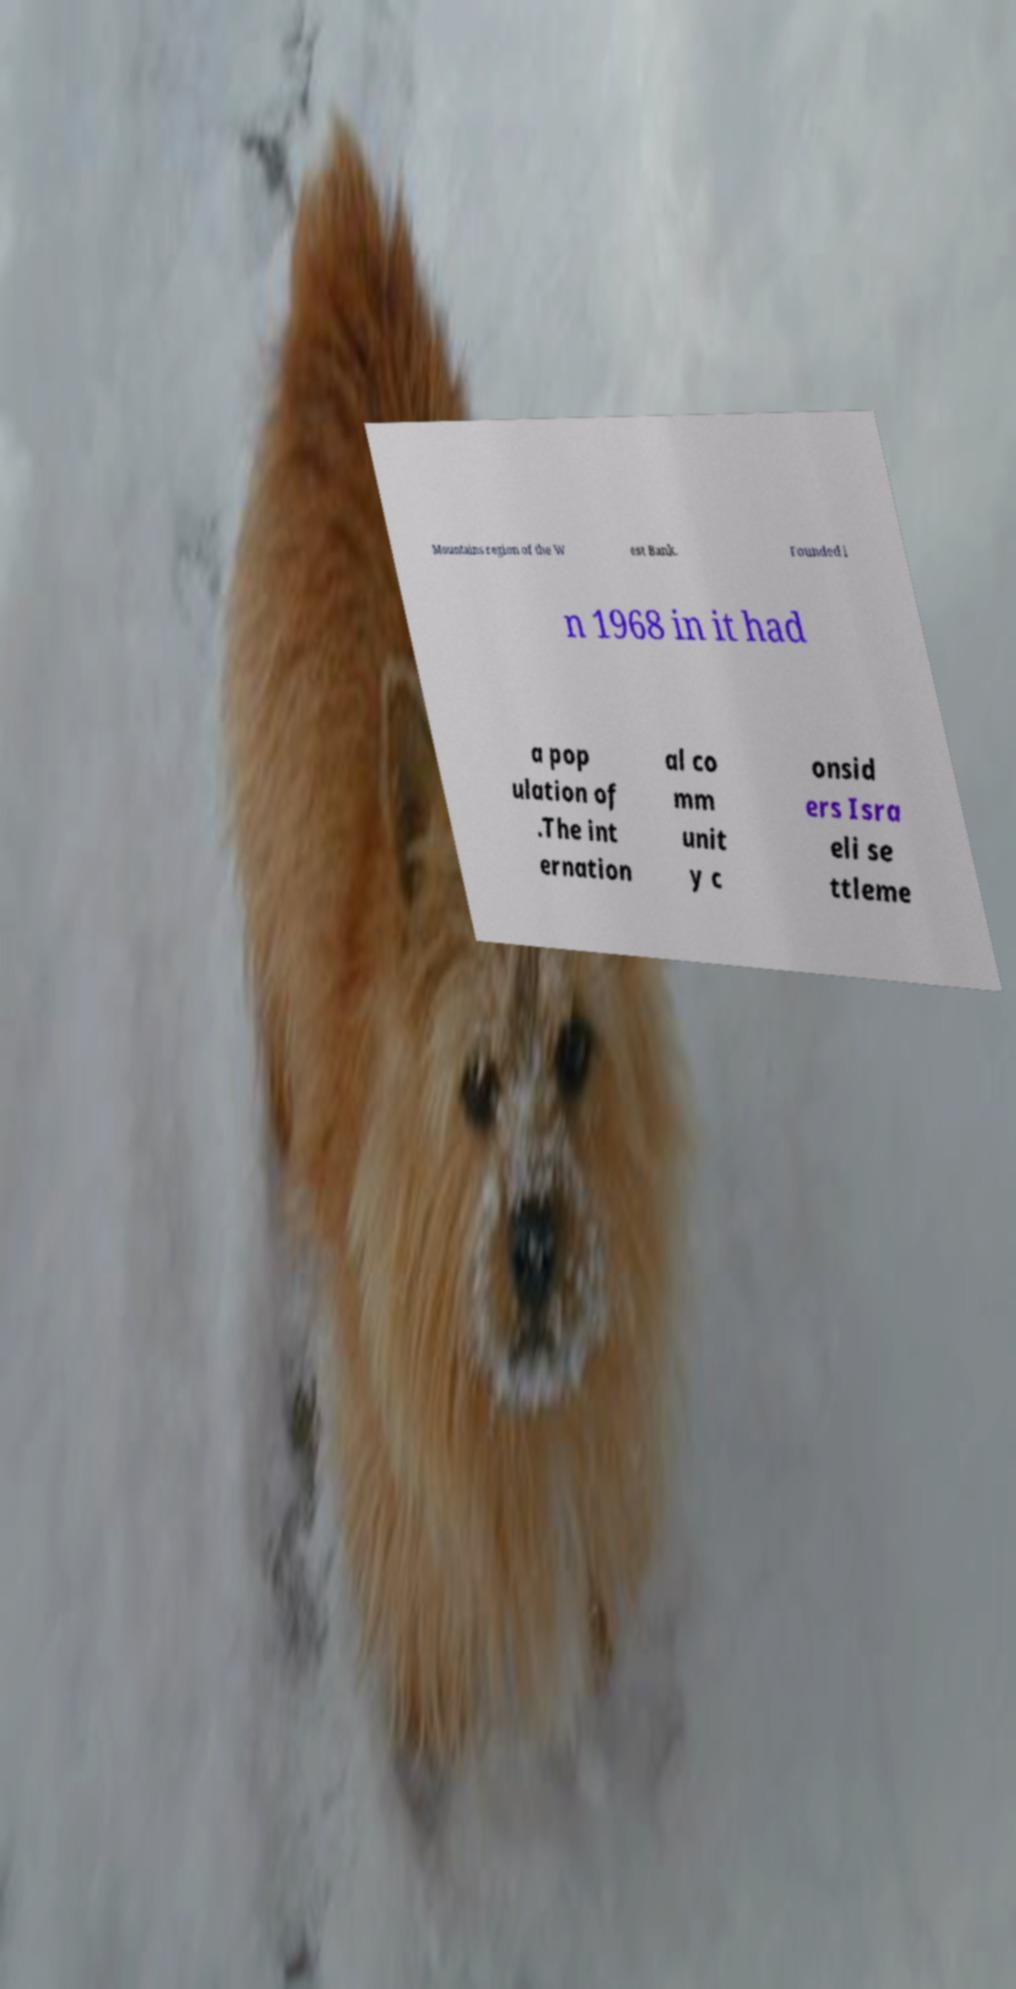Could you assist in decoding the text presented in this image and type it out clearly? Mountains region of the W est Bank. Founded i n 1968 in it had a pop ulation of .The int ernation al co mm unit y c onsid ers Isra eli se ttleme 